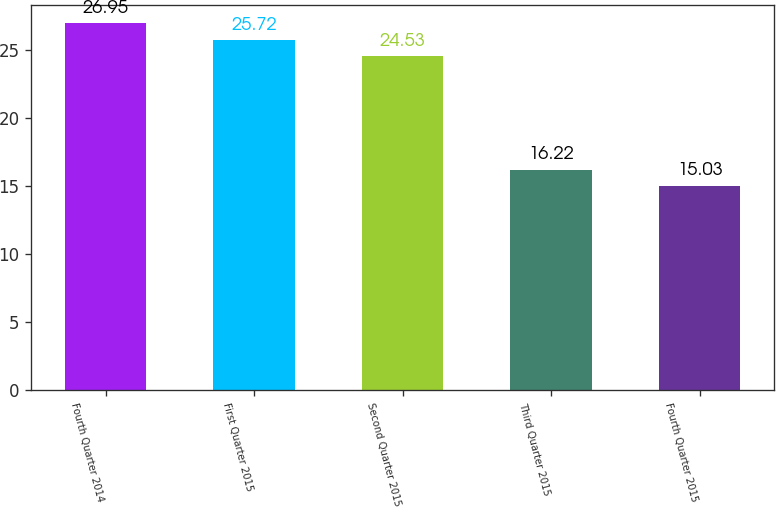Convert chart. <chart><loc_0><loc_0><loc_500><loc_500><bar_chart><fcel>Fourth Quarter 2014<fcel>First Quarter 2015<fcel>Second Quarter 2015<fcel>Third Quarter 2015<fcel>Fourth Quarter 2015<nl><fcel>26.95<fcel>25.72<fcel>24.53<fcel>16.22<fcel>15.03<nl></chart> 